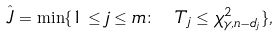<formula> <loc_0><loc_0><loc_500><loc_500>\hat { J } = \min \{ 1 \leq j \leq m \colon \ T _ { j } \leq \chi ^ { 2 } _ { \gamma , n - d _ { j } } \} ,</formula> 